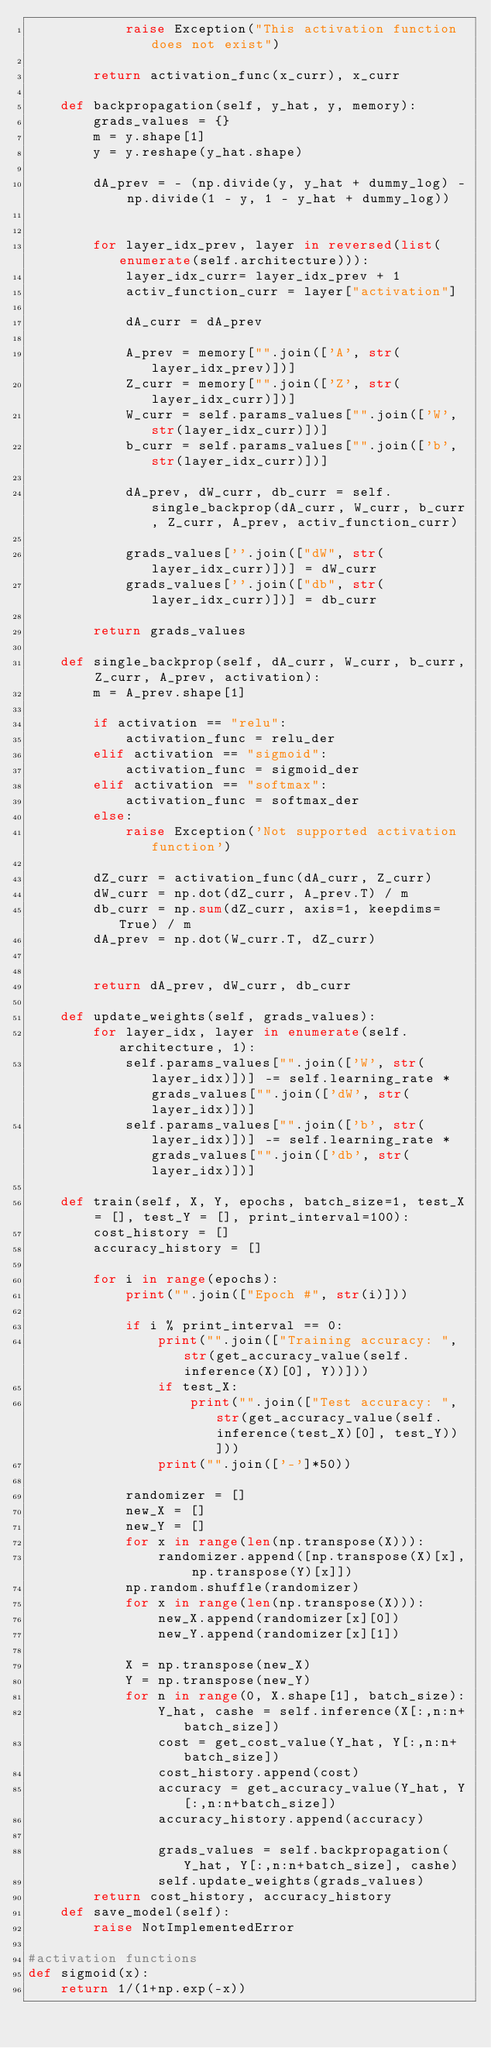<code> <loc_0><loc_0><loc_500><loc_500><_Python_>            raise Exception("This activation function does not exist")

        return activation_func(x_curr), x_curr

    def backpropagation(self, y_hat, y, memory):
        grads_values = {}
        m = y.shape[1]
        y = y.reshape(y_hat.shape)

        dA_prev = - (np.divide(y, y_hat + dummy_log) - np.divide(1 - y, 1 - y_hat + dummy_log))


        for layer_idx_prev, layer in reversed(list(enumerate(self.architecture))):
            layer_idx_curr= layer_idx_prev + 1
            activ_function_curr = layer["activation"]

            dA_curr = dA_prev
            
            A_prev = memory["".join(['A', str(layer_idx_prev)])]
            Z_curr = memory["".join(['Z', str(layer_idx_curr)])]
            W_curr = self.params_values["".join(['W', str(layer_idx_curr)])]
            b_curr = self.params_values["".join(['b', str(layer_idx_curr)])]

            dA_prev, dW_curr, db_curr = self.single_backprop(dA_curr, W_curr, b_curr, Z_curr, A_prev, activ_function_curr)

            grads_values[''.join(["dW", str(layer_idx_curr)])] = dW_curr
            grads_values[''.join(["db", str(layer_idx_curr)])] = db_curr
    
        return grads_values

    def single_backprop(self, dA_curr, W_curr, b_curr, Z_curr, A_prev, activation):
        m = A_prev.shape[1]

        if activation == "relu":
            activation_func = relu_der
        elif activation == "sigmoid":
            activation_func = sigmoid_der
        elif activation == "softmax":
            activation_func = softmax_der
        else:
            raise Exception('Not supported activation function')

        dZ_curr = activation_func(dA_curr, Z_curr) 
        dW_curr = np.dot(dZ_curr, A_prev.T) / m
        db_curr = np.sum(dZ_curr, axis=1, keepdims=True) / m
        dA_prev = np.dot(W_curr.T, dZ_curr)


        return dA_prev, dW_curr, db_curr
        
    def update_weights(self, grads_values):
        for layer_idx, layer in enumerate(self.architecture, 1):
            self.params_values["".join(['W', str(layer_idx)])] -= self.learning_rate * grads_values["".join(['dW', str(layer_idx)])]
            self.params_values["".join(['b', str(layer_idx)])] -= self.learning_rate * grads_values["".join(['db', str(layer_idx)])]

    def train(self, X, Y, epochs, batch_size=1, test_X = [], test_Y = [], print_interval=100):
        cost_history = []
        accuracy_history = []

        for i in range(epochs):
            print("".join(["Epoch #", str(i)]))

            if i % print_interval == 0:
                print("".join(["Training accuracy: ", str(get_accuracy_value(self.inference(X)[0], Y))]))
                if test_X:
                    print("".join(["Test accuracy: ", str(get_accuracy_value(self.inference(test_X)[0], test_Y))]))
                print("".join(['-']*50))

            randomizer = []
            new_X = []
            new_Y = []
            for x in range(len(np.transpose(X))):
                randomizer.append([np.transpose(X)[x], np.transpose(Y)[x]])
            np.random.shuffle(randomizer)
            for x in range(len(np.transpose(X))):
                new_X.append(randomizer[x][0])
                new_Y.append(randomizer[x][1])

            X = np.transpose(new_X)
            Y = np.transpose(new_Y)
            for n in range(0, X.shape[1], batch_size):
                Y_hat, cashe = self.inference(X[:,n:n+batch_size])
                cost = get_cost_value(Y_hat, Y[:,n:n+batch_size])
                cost_history.append(cost)
                accuracy = get_accuracy_value(Y_hat, Y[:,n:n+batch_size])
                accuracy_history.append(accuracy)

                grads_values = self.backpropagation(Y_hat, Y[:,n:n+batch_size], cashe)
                self.update_weights(grads_values)
        return cost_history, accuracy_history
    def save_model(self):
        raise NotImplementedError

#activation functions
def sigmoid(x):
    return 1/(1+np.exp(-x))</code> 